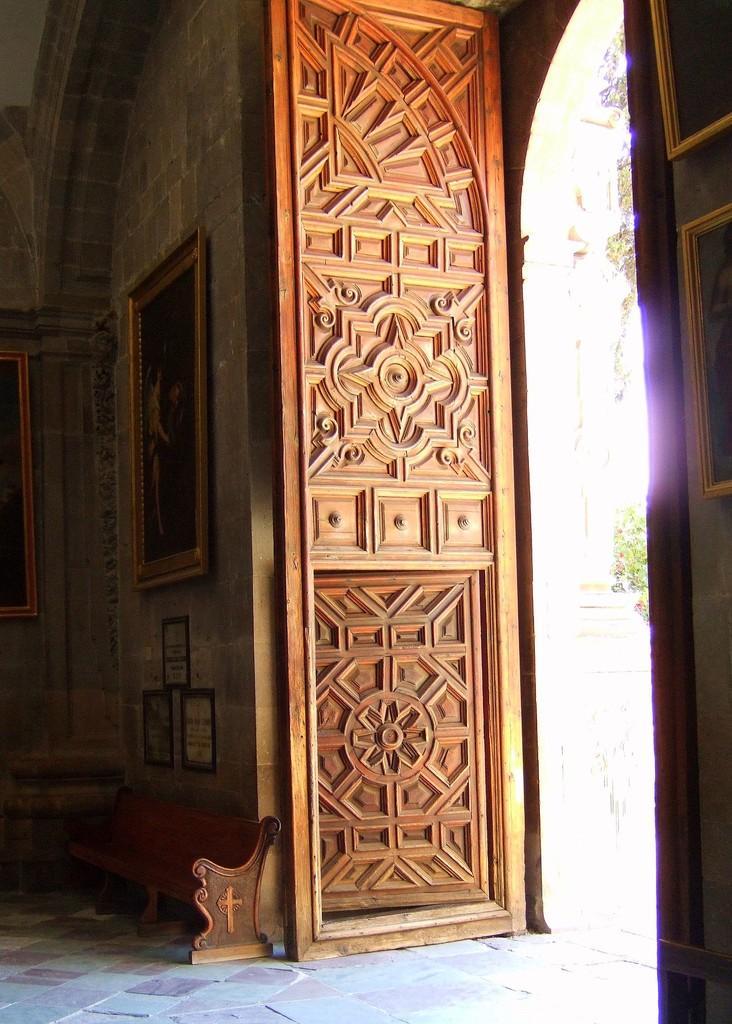How would you summarize this image in a sentence or two? In this image there is a door of the building, inside the building there are a few frames attached to the wall, a bench, outside the building there is a tree. 